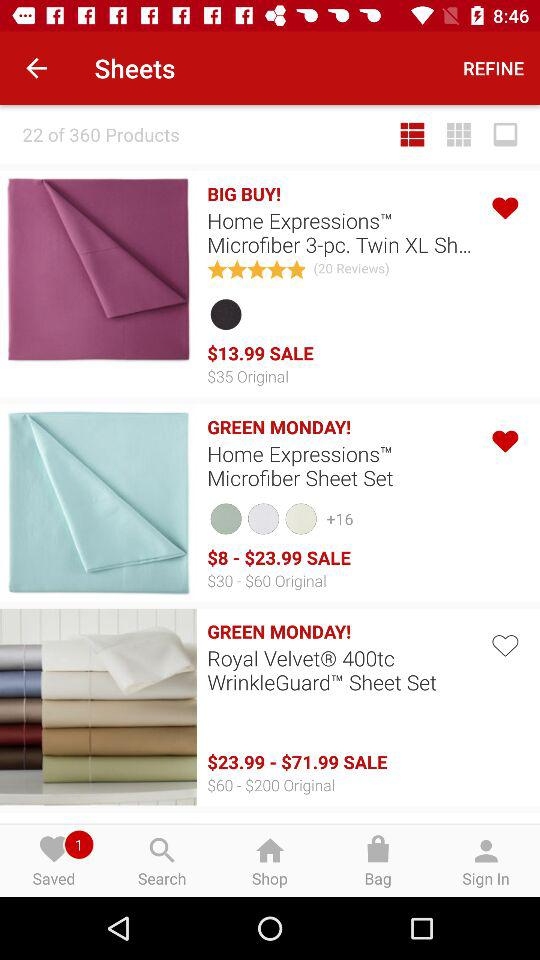What is the price of the "Home Expressions Microfiber Sheet Set"? The price of the "Home Expressions Microfiber Sheet Set" ranges from $8 to $23.99. 